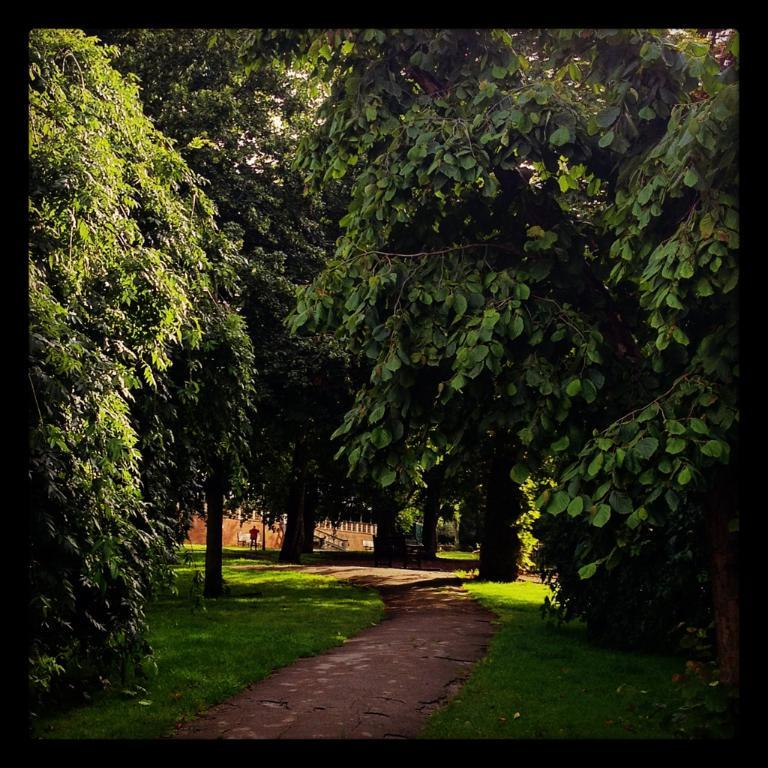What type of vegetation is present in the image? There is grass in the image. What other natural elements can be seen in the image? There are trees in the image. What can be seen in the background of the image? There is a building and a person in the background of the image. What type of print is visible on the horse's suit in the image? There is no horse or suit present in the image; it features grass, trees, a building, and a person. 